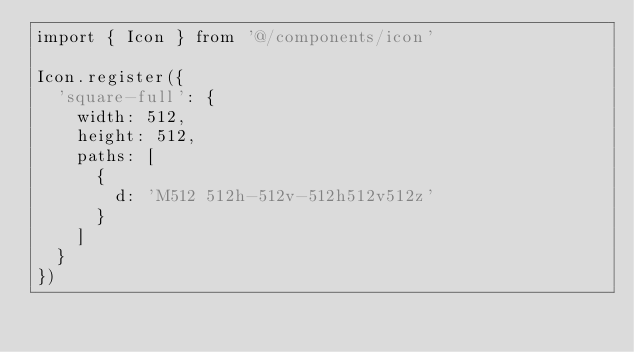<code> <loc_0><loc_0><loc_500><loc_500><_TypeScript_>import { Icon } from '@/components/icon'

Icon.register({
  'square-full': {
    width: 512,
    height: 512,
    paths: [
      {
        d: 'M512 512h-512v-512h512v512z'
      }
    ]
  }
})
</code> 